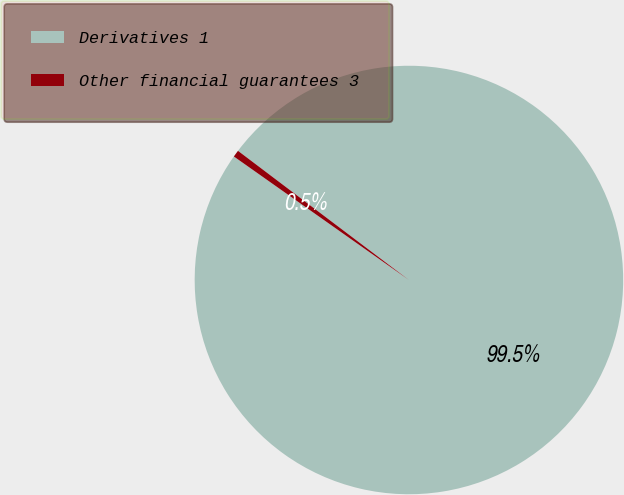<chart> <loc_0><loc_0><loc_500><loc_500><pie_chart><fcel>Derivatives 1<fcel>Other financial guarantees 3<nl><fcel>99.48%<fcel>0.52%<nl></chart> 